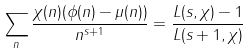Convert formula to latex. <formula><loc_0><loc_0><loc_500><loc_500>\sum _ { n } \frac { \chi ( n ) ( \phi ( n ) - \mu ( n ) ) } { n ^ { s + 1 } } = \frac { L ( s , \chi ) - 1 } { L ( s + 1 , \chi ) }</formula> 